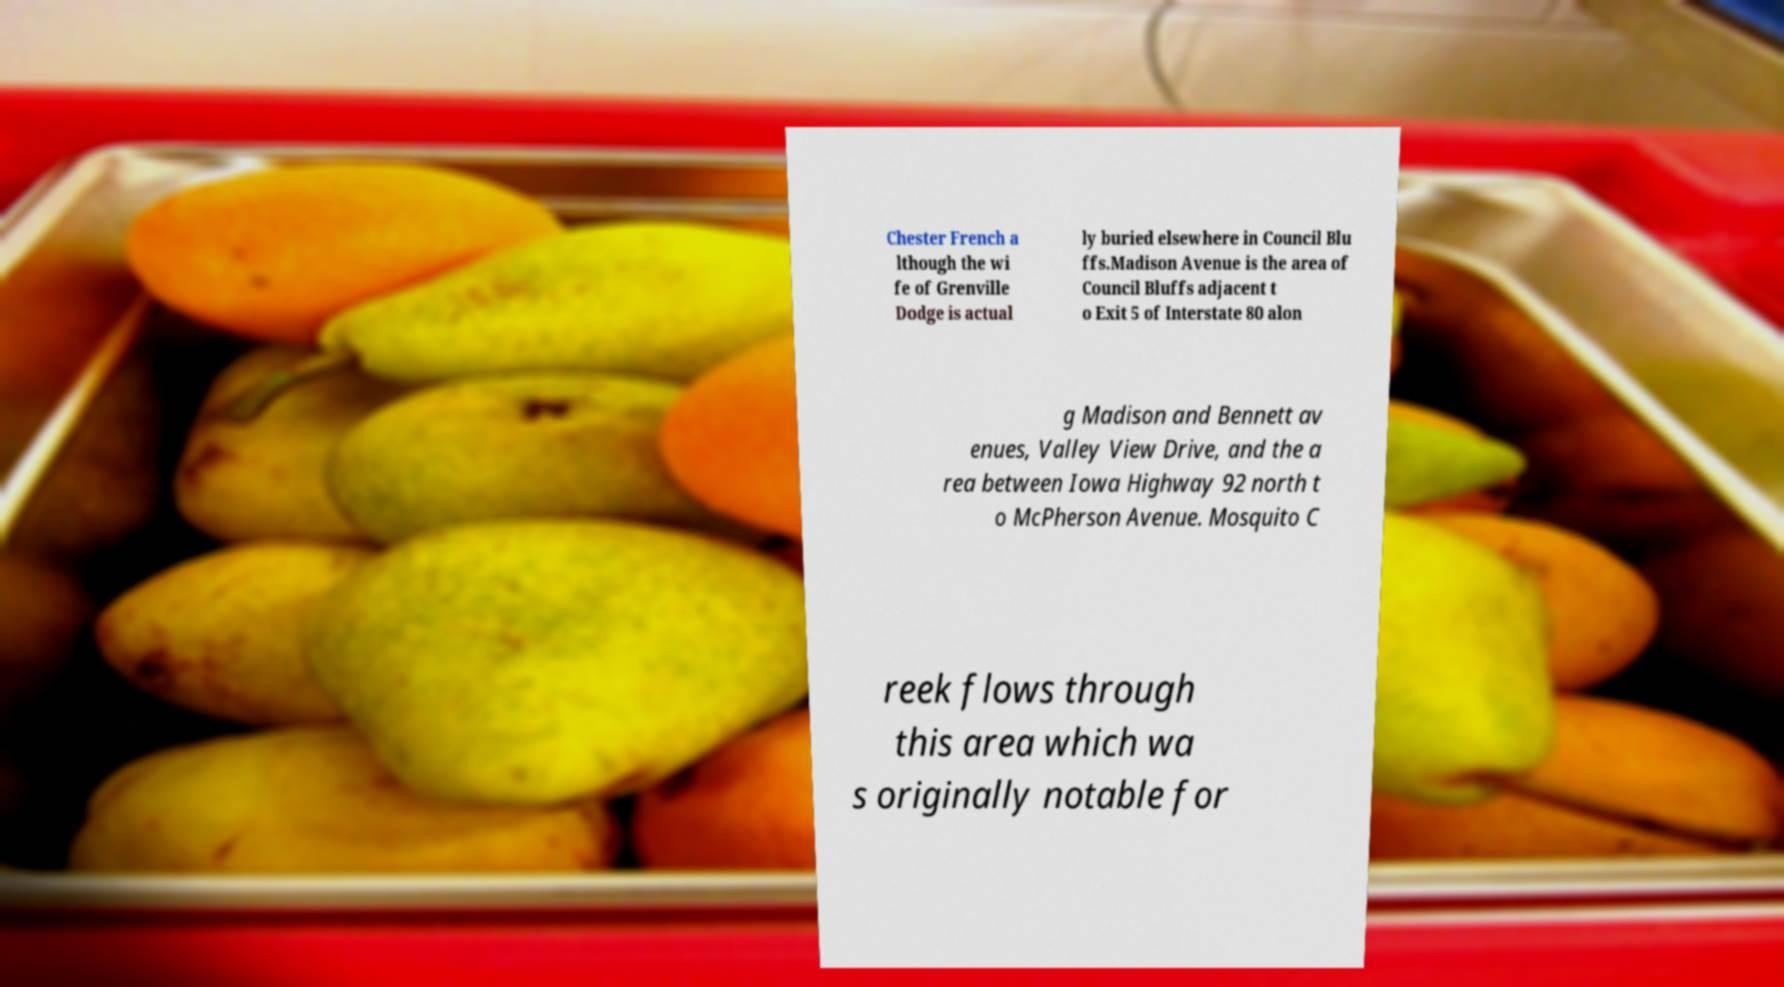What messages or text are displayed in this image? I need them in a readable, typed format. Chester French a lthough the wi fe of Grenville Dodge is actual ly buried elsewhere in Council Blu ffs.Madison Avenue is the area of Council Bluffs adjacent t o Exit 5 of Interstate 80 alon g Madison and Bennett av enues, Valley View Drive, and the a rea between Iowa Highway 92 north t o McPherson Avenue. Mosquito C reek flows through this area which wa s originally notable for 